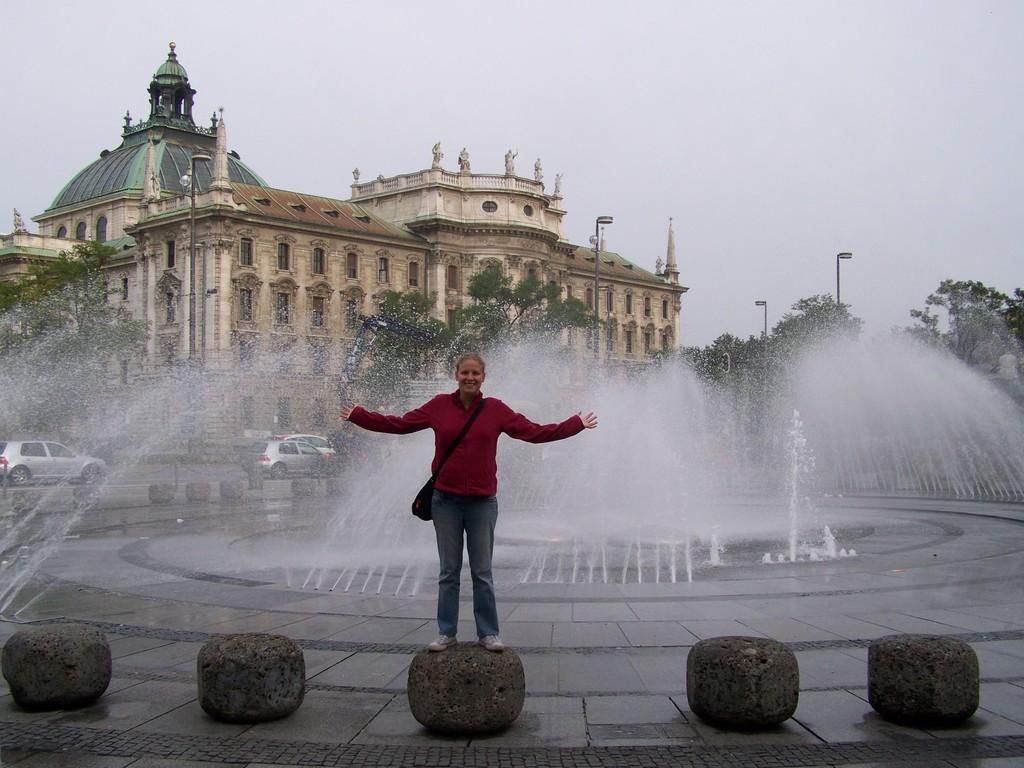Please provide a concise description of this image. In this picture I can see a person standing on the stone. I can see the fountain. I can see the building in the background. I can see vehicles on the road. I can see light pole. I can see trees. I can see clouds in the sky. 